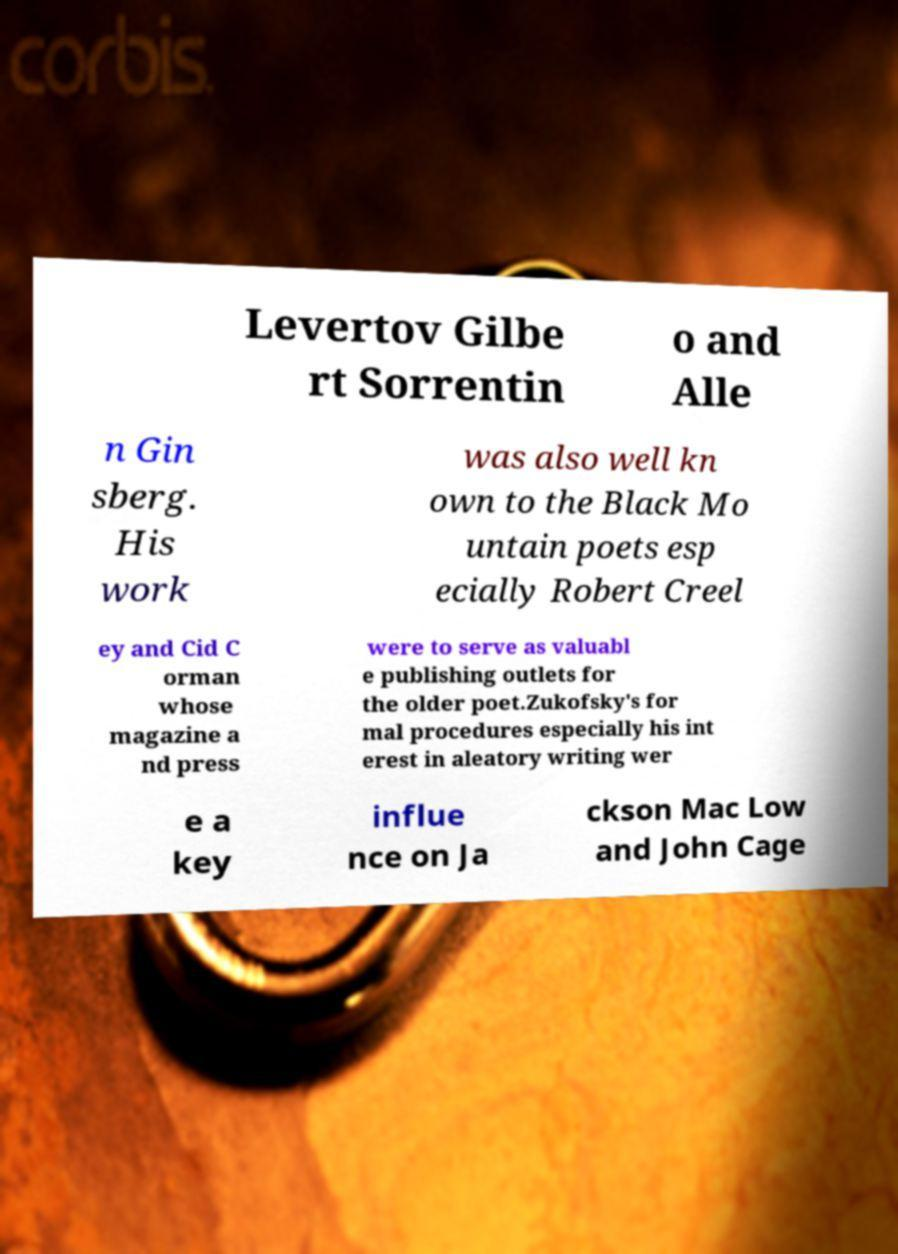Can you read and provide the text displayed in the image?This photo seems to have some interesting text. Can you extract and type it out for me? Levertov Gilbe rt Sorrentin o and Alle n Gin sberg. His work was also well kn own to the Black Mo untain poets esp ecially Robert Creel ey and Cid C orman whose magazine a nd press were to serve as valuabl e publishing outlets for the older poet.Zukofsky's for mal procedures especially his int erest in aleatory writing wer e a key influe nce on Ja ckson Mac Low and John Cage 